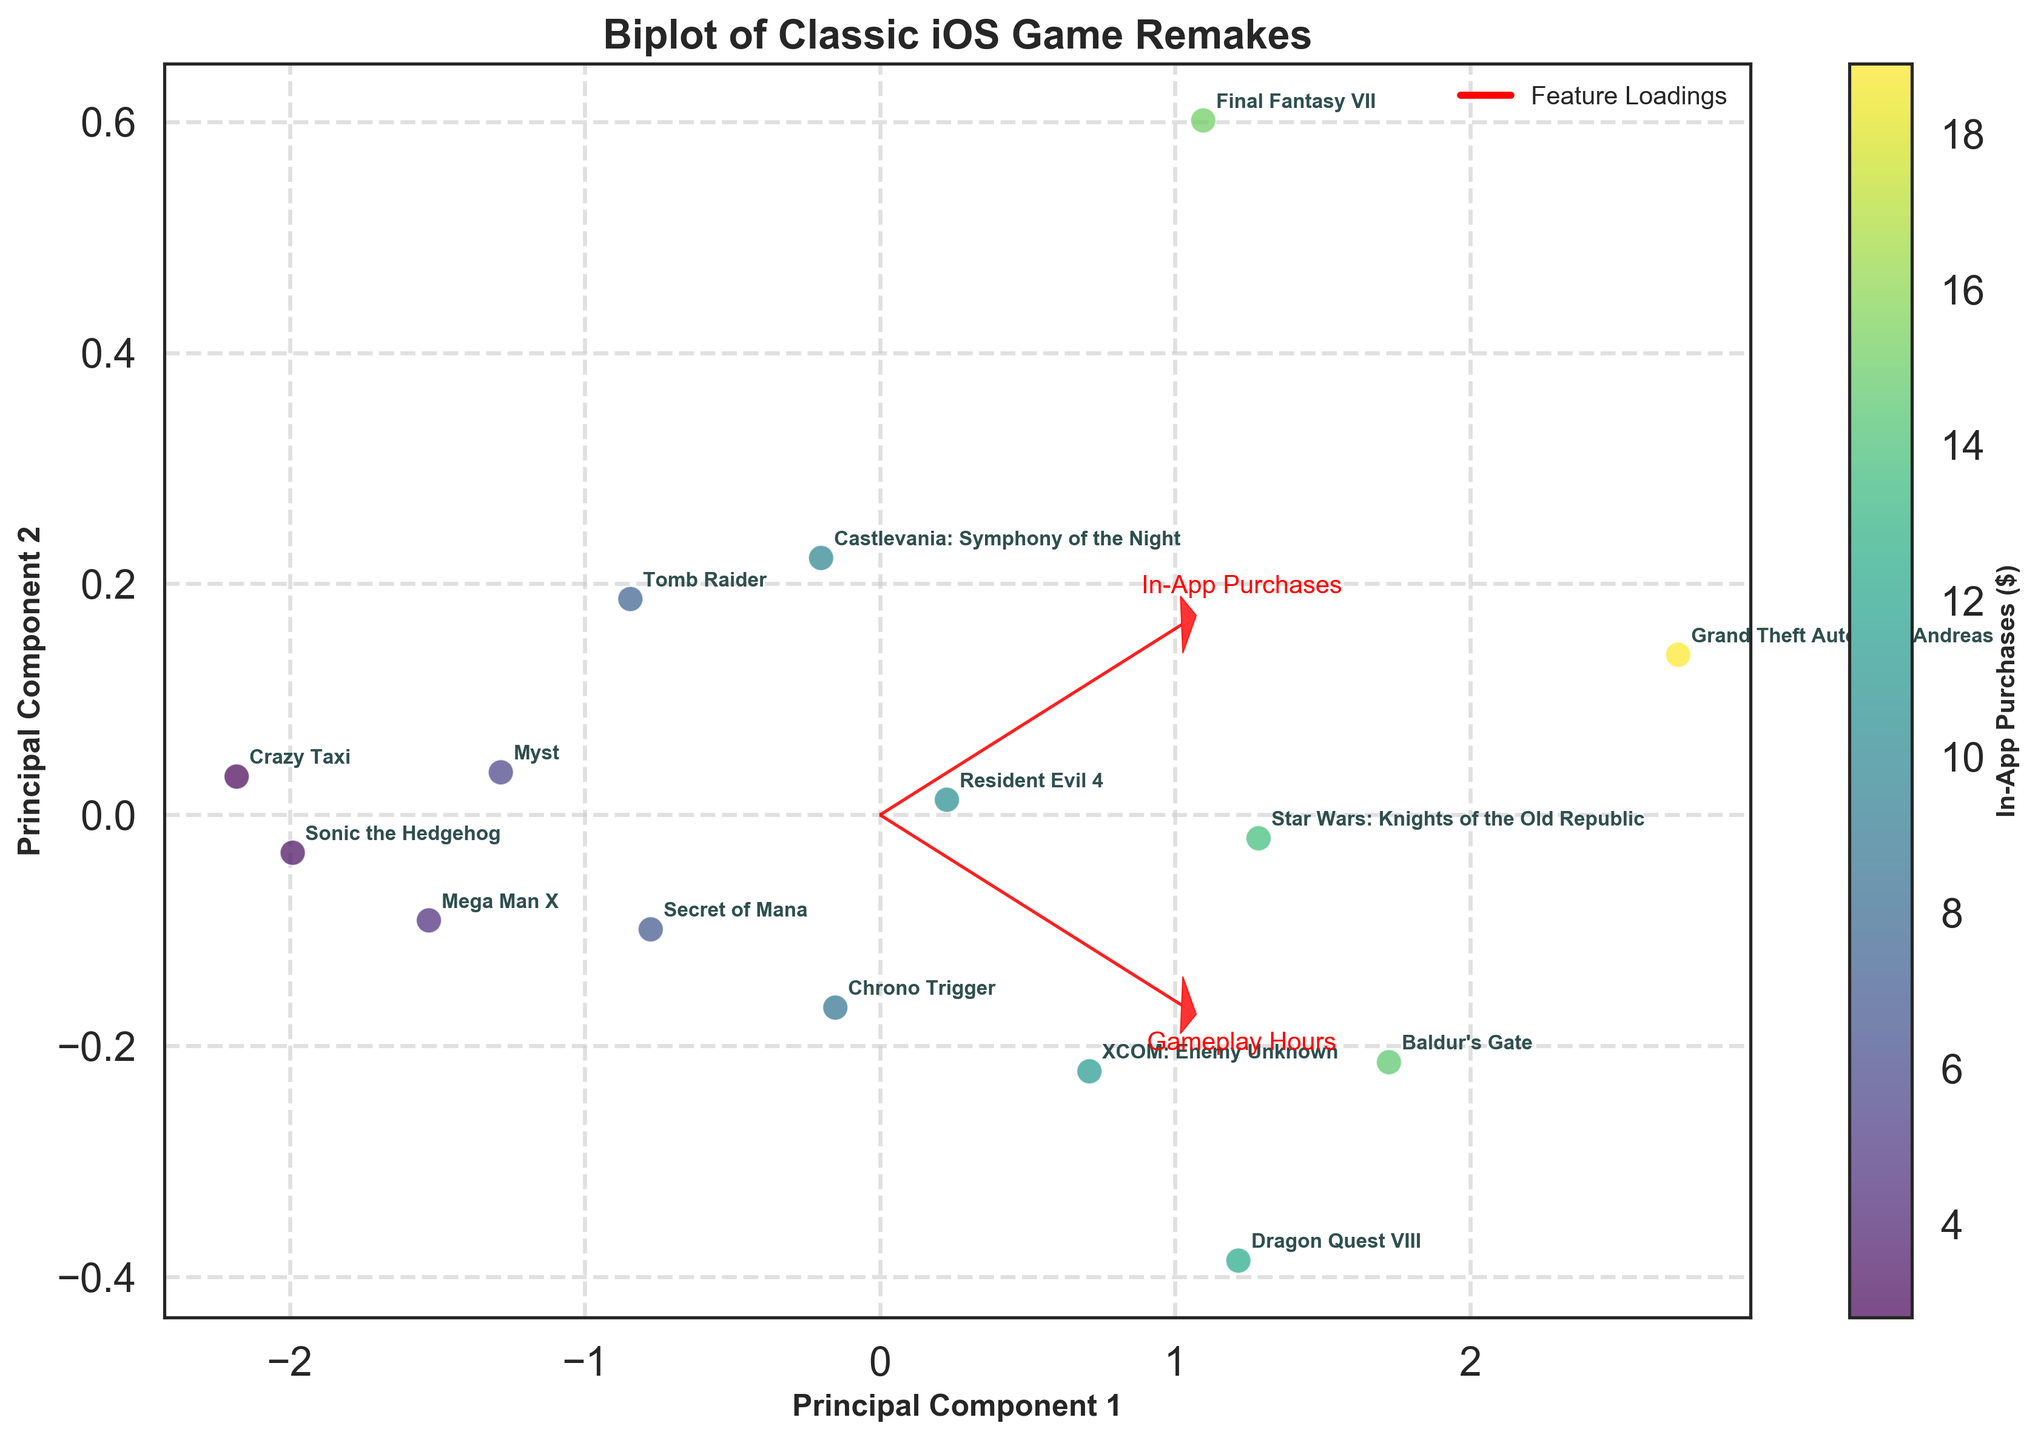What is the title of the Biplot? The title of the plot is typically displayed prominently at the top of the figure. In this case, you can see the text 'Biplot of Classic iOS Game Remakes' clearly indicating what the figure represents.
Answer: Biplot of Classic iOS Game Remakes Which game has the highest gameplay hours? To determine this, you need to identify the point farthest along the axis associated with gameplay hours. By looking at where the data points are annotated, Grand Theft Auto: San Andreas is situated far along the gameplay hours axis.
Answer: Grand Theft Auto: San Andreas Between 'Mega Man X' and 'Myst,' which game has higher in-app purchases and by how much? Locate both game labels on the figure and observe their position in relation to the in-app purchases axis. Mega Man X is relatively lower in this axis compared to Myst. Mega Man X is at $4.5 and Myst is at $5.7. The difference is $5.7 - $4.5.
Answer: Myst by $1.2 Which feature contributes more to Principal Component 1, 'In-App Purchases' or 'Gameplay Hours'? The loading vectors indicate the contribution to each principal component. By checking the orientation of the arrows, you see which component each feature is contributing more towards. In-App Purchases seems to contribute more to the first principal component due to its longer arrow length.
Answer: In-App Purchases What is the color mapping used in the Biplot, and how is it represented? The scatter plot uses a color gradient to represent the in-app purchases, using different shades that range based on values. The color bar on the right side of the figure demonstrates this mapping from lower to higher values.
Answer: In-App Purchases ($) Which game is closest to the origin of the plot? Find the game label situated nearest to the (0, 0) point in the biplot. Crazy Taxi appears to be located closest to the origin.
Answer: Crazy Taxi How do 'Final Fantasy VII' and 'Baldur’s Gate' compare in terms of gameplay hours? Check their labels in the figure and align these with the gameplay hours axis. Final Fantasy VII has about 42.3 hours while Baldur’s Gate has approximately 59.8 hours. Baldur’s Gate has more gameplay hours.
Answer: Baldur’s Gate has more gameplay hours What does the red arrow represent in the biplot, and what information does it provide? The red arrows are loading vectors, which show how much each feature (In-App Purchases and Gameplay Hours) contributes to the principal components. They help in understanding the direction and magnitude of influence each feature has in the data projection.
Answer: Feature Loadings Identify a game with moderate gameplay hours and moderate in-app purchases. Moderate values can be found around the midpoint of the axes and the color gradient. 'Resident Evil 4' seems to have balanced values of both in-app purchases and gameplay hours, placing it in a moderate range.
Answer: Resident Evil 4 